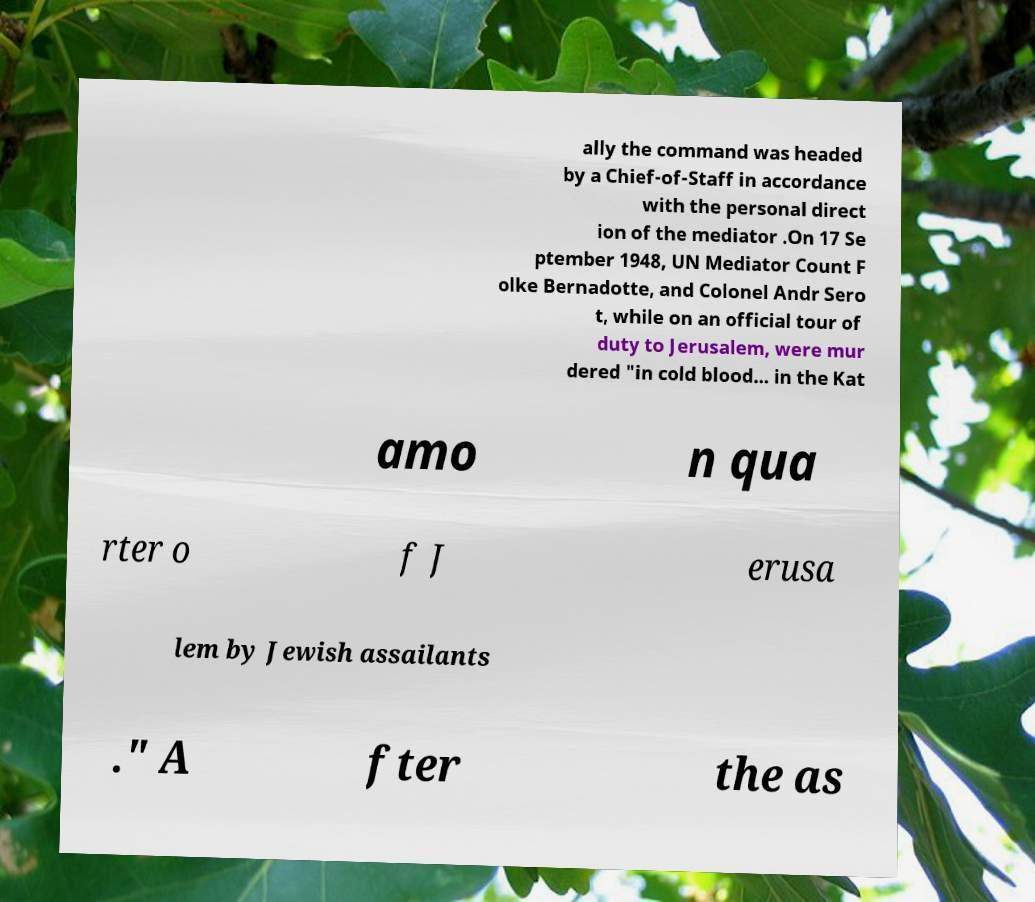Please read and relay the text visible in this image. What does it say? ally the command was headed by a Chief-of-Staff in accordance with the personal direct ion of the mediator .On 17 Se ptember 1948, UN Mediator Count F olke Bernadotte, and Colonel Andr Sero t, while on an official tour of duty to Jerusalem, were mur dered "in cold blood... in the Kat amo n qua rter o f J erusa lem by Jewish assailants ." A fter the as 